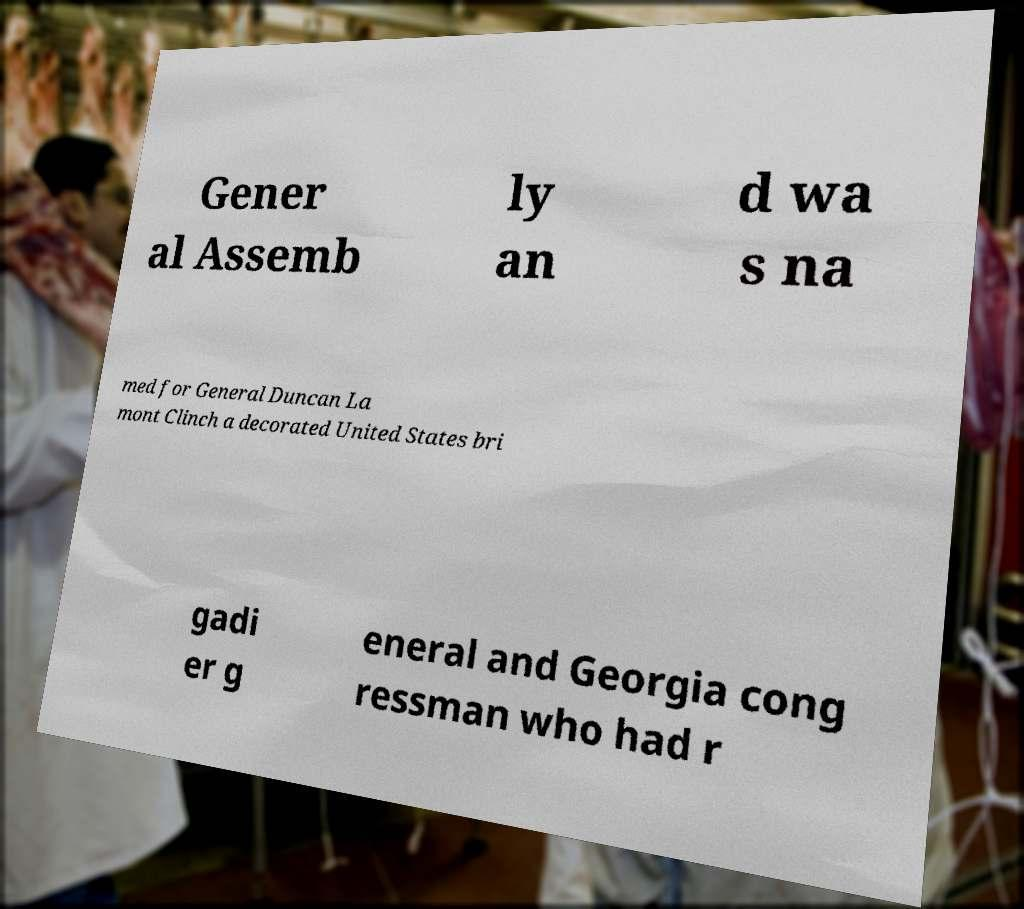Please read and relay the text visible in this image. What does it say? Gener al Assemb ly an d wa s na med for General Duncan La mont Clinch a decorated United States bri gadi er g eneral and Georgia cong ressman who had r 